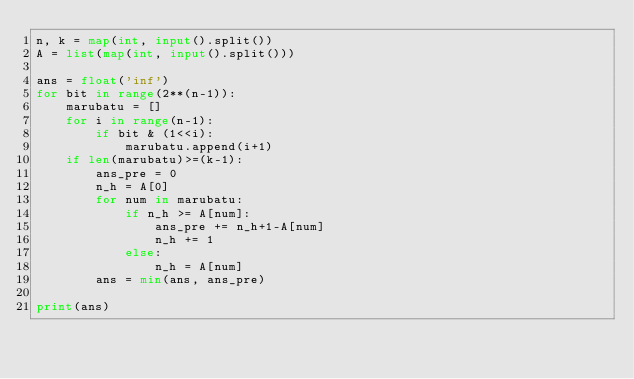<code> <loc_0><loc_0><loc_500><loc_500><_Python_>n, k = map(int, input().split())
A = list(map(int, input().split()))

ans = float('inf')
for bit in range(2**(n-1)):
    marubatu = []
    for i in range(n-1):
        if bit & (1<<i):
            marubatu.append(i+1)
    if len(marubatu)>=(k-1):
        ans_pre = 0
        n_h = A[0]
        for num in marubatu:
            if n_h >= A[num]:
                ans_pre += n_h+1-A[num]
                n_h += 1
            else:
                n_h = A[num]
        ans = min(ans, ans_pre)
    
print(ans)</code> 